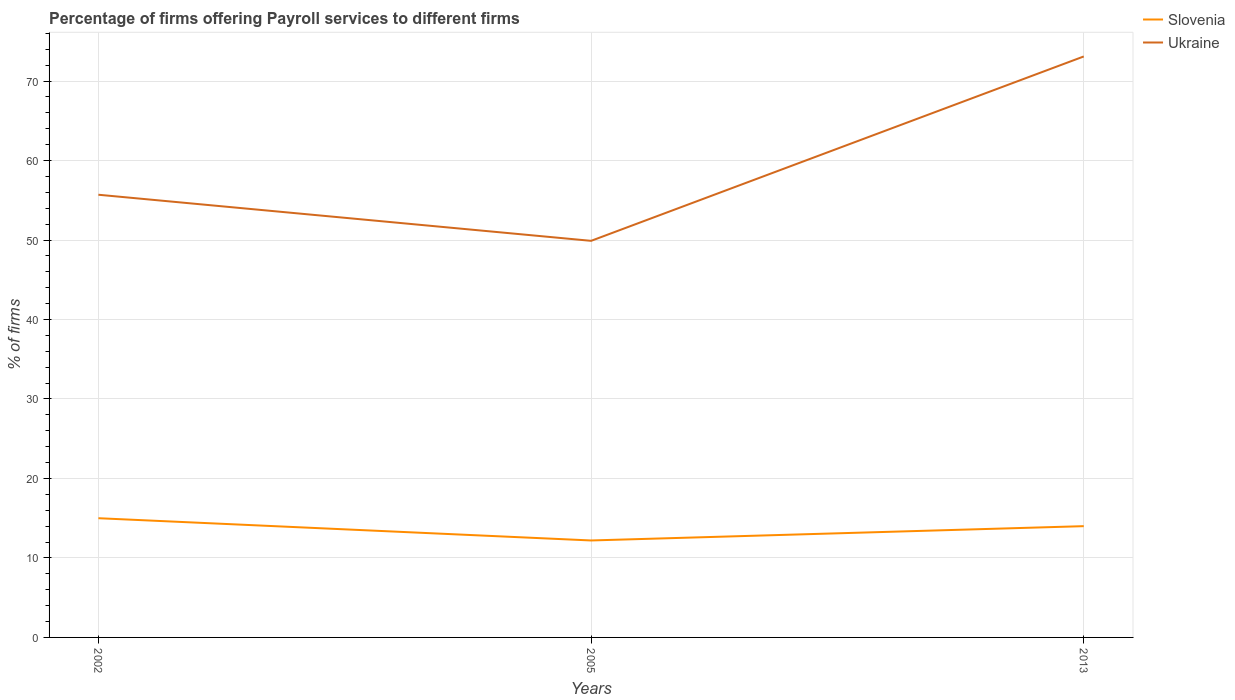Is the number of lines equal to the number of legend labels?
Keep it short and to the point. Yes. Across all years, what is the maximum percentage of firms offering payroll services in Ukraine?
Give a very brief answer. 49.9. In which year was the percentage of firms offering payroll services in Ukraine maximum?
Give a very brief answer. 2005. What is the total percentage of firms offering payroll services in Slovenia in the graph?
Your response must be concise. -1.8. What is the difference between the highest and the second highest percentage of firms offering payroll services in Slovenia?
Your answer should be very brief. 2.8. Is the percentage of firms offering payroll services in Slovenia strictly greater than the percentage of firms offering payroll services in Ukraine over the years?
Make the answer very short. Yes. How many lines are there?
Keep it short and to the point. 2. Does the graph contain any zero values?
Keep it short and to the point. No. How are the legend labels stacked?
Keep it short and to the point. Vertical. What is the title of the graph?
Your answer should be compact. Percentage of firms offering Payroll services to different firms. Does "St. Martin (French part)" appear as one of the legend labels in the graph?
Keep it short and to the point. No. What is the label or title of the Y-axis?
Provide a succinct answer. % of firms. What is the % of firms in Slovenia in 2002?
Keep it short and to the point. 15. What is the % of firms of Ukraine in 2002?
Provide a succinct answer. 55.7. What is the % of firms in Ukraine in 2005?
Give a very brief answer. 49.9. What is the % of firms of Slovenia in 2013?
Provide a succinct answer. 14. What is the % of firms of Ukraine in 2013?
Make the answer very short. 73.1. Across all years, what is the maximum % of firms of Slovenia?
Ensure brevity in your answer.  15. Across all years, what is the maximum % of firms of Ukraine?
Your answer should be very brief. 73.1. Across all years, what is the minimum % of firms of Slovenia?
Give a very brief answer. 12.2. Across all years, what is the minimum % of firms of Ukraine?
Offer a very short reply. 49.9. What is the total % of firms in Slovenia in the graph?
Give a very brief answer. 41.2. What is the total % of firms in Ukraine in the graph?
Provide a short and direct response. 178.7. What is the difference between the % of firms in Ukraine in 2002 and that in 2005?
Your answer should be very brief. 5.8. What is the difference between the % of firms of Ukraine in 2002 and that in 2013?
Keep it short and to the point. -17.4. What is the difference between the % of firms of Slovenia in 2005 and that in 2013?
Make the answer very short. -1.8. What is the difference between the % of firms of Ukraine in 2005 and that in 2013?
Provide a succinct answer. -23.2. What is the difference between the % of firms of Slovenia in 2002 and the % of firms of Ukraine in 2005?
Make the answer very short. -34.9. What is the difference between the % of firms in Slovenia in 2002 and the % of firms in Ukraine in 2013?
Your answer should be very brief. -58.1. What is the difference between the % of firms in Slovenia in 2005 and the % of firms in Ukraine in 2013?
Ensure brevity in your answer.  -60.9. What is the average % of firms in Slovenia per year?
Ensure brevity in your answer.  13.73. What is the average % of firms of Ukraine per year?
Keep it short and to the point. 59.57. In the year 2002, what is the difference between the % of firms of Slovenia and % of firms of Ukraine?
Make the answer very short. -40.7. In the year 2005, what is the difference between the % of firms in Slovenia and % of firms in Ukraine?
Provide a succinct answer. -37.7. In the year 2013, what is the difference between the % of firms in Slovenia and % of firms in Ukraine?
Ensure brevity in your answer.  -59.1. What is the ratio of the % of firms of Slovenia in 2002 to that in 2005?
Your answer should be compact. 1.23. What is the ratio of the % of firms of Ukraine in 2002 to that in 2005?
Your answer should be very brief. 1.12. What is the ratio of the % of firms in Slovenia in 2002 to that in 2013?
Provide a short and direct response. 1.07. What is the ratio of the % of firms in Ukraine in 2002 to that in 2013?
Provide a short and direct response. 0.76. What is the ratio of the % of firms of Slovenia in 2005 to that in 2013?
Provide a short and direct response. 0.87. What is the ratio of the % of firms in Ukraine in 2005 to that in 2013?
Offer a terse response. 0.68. What is the difference between the highest and the second highest % of firms of Slovenia?
Provide a succinct answer. 1. What is the difference between the highest and the lowest % of firms in Slovenia?
Offer a terse response. 2.8. What is the difference between the highest and the lowest % of firms of Ukraine?
Make the answer very short. 23.2. 